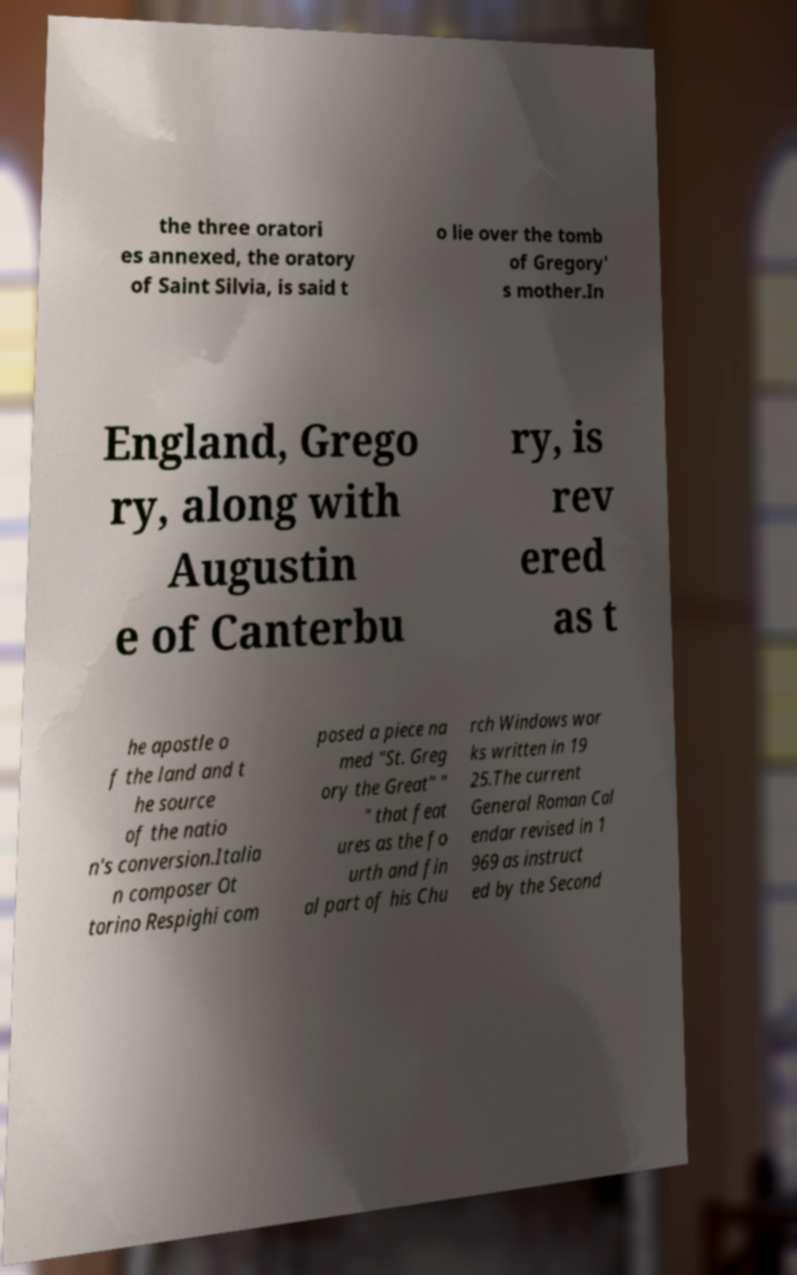Please identify and transcribe the text found in this image. the three oratori es annexed, the oratory of Saint Silvia, is said t o lie over the tomb of Gregory' s mother.In England, Grego ry, along with Augustin e of Canterbu ry, is rev ered as t he apostle o f the land and t he source of the natio n's conversion.Italia n composer Ot torino Respighi com posed a piece na med "St. Greg ory the Great" " " that feat ures as the fo urth and fin al part of his Chu rch Windows wor ks written in 19 25.The current General Roman Cal endar revised in 1 969 as instruct ed by the Second 